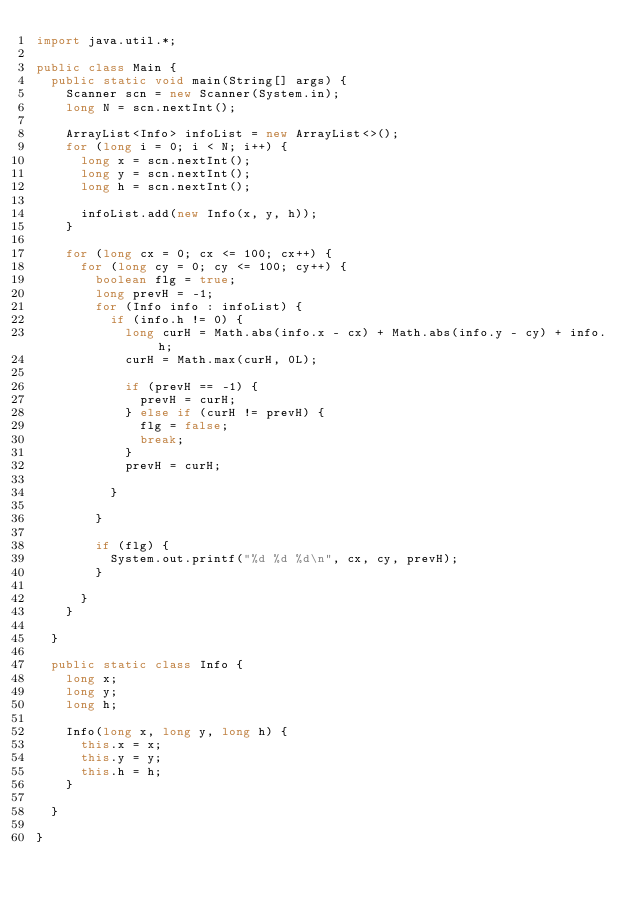Convert code to text. <code><loc_0><loc_0><loc_500><loc_500><_Java_>import java.util.*;

public class Main {
  public static void main(String[] args) {
    Scanner scn = new Scanner(System.in);
    long N = scn.nextInt();

    ArrayList<Info> infoList = new ArrayList<>();
    for (long i = 0; i < N; i++) {
      long x = scn.nextInt();
      long y = scn.nextInt();
      long h = scn.nextInt();

      infoList.add(new Info(x, y, h));
    }

    for (long cx = 0; cx <= 100; cx++) {
      for (long cy = 0; cy <= 100; cy++) {
        boolean flg = true;
        long prevH = -1;
        for (Info info : infoList) {
          if (info.h != 0) {
            long curH = Math.abs(info.x - cx) + Math.abs(info.y - cy) + info.h;
            curH = Math.max(curH, 0L);

            if (prevH == -1) {
              prevH = curH;
            } else if (curH != prevH) {
              flg = false;
              break;
            }
            prevH = curH;

          }

        }

        if (flg) {
          System.out.printf("%d %d %d\n", cx, cy, prevH);
        }

      }
    }

  }

  public static class Info {
    long x;
    long y;
    long h;

    Info(long x, long y, long h) {
      this.x = x;
      this.y = y;
      this.h = h;
    }

  }

}
</code> 